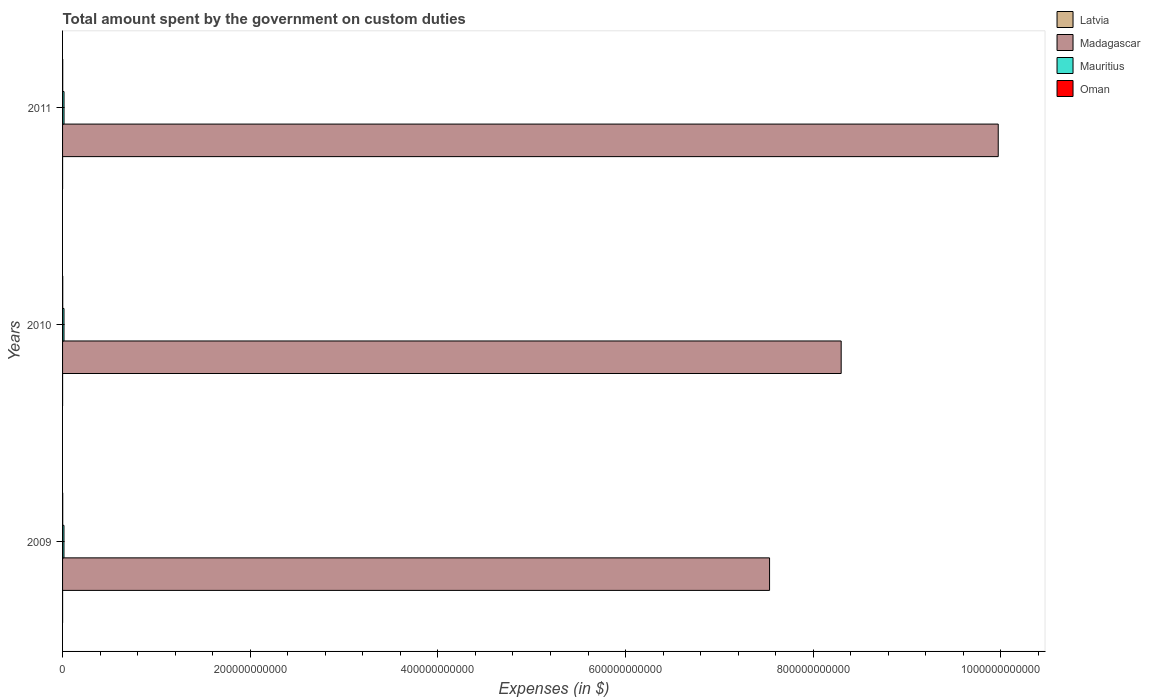Are the number of bars on each tick of the Y-axis equal?
Give a very brief answer. Yes. How many bars are there on the 1st tick from the top?
Give a very brief answer. 4. How many bars are there on the 1st tick from the bottom?
Your answer should be compact. 4. What is the amount spent on custom duties by the government in Mauritius in 2010?
Your response must be concise. 1.53e+09. Across all years, what is the maximum amount spent on custom duties by the government in Madagascar?
Provide a succinct answer. 9.97e+11. Across all years, what is the minimum amount spent on custom duties by the government in Madagascar?
Provide a succinct answer. 7.53e+11. In which year was the amount spent on custom duties by the government in Oman maximum?
Make the answer very short. 2010. In which year was the amount spent on custom duties by the government in Mauritius minimum?
Offer a terse response. 2009. What is the total amount spent on custom duties by the government in Madagascar in the graph?
Your response must be concise. 2.58e+12. What is the difference between the amount spent on custom duties by the government in Latvia in 2009 and that in 2011?
Provide a short and direct response. -5.80e+06. What is the difference between the amount spent on custom duties by the government in Mauritius in 2010 and the amount spent on custom duties by the government in Madagascar in 2009?
Provide a short and direct response. -7.52e+11. What is the average amount spent on custom duties by the government in Latvia per year?
Make the answer very short. 1.77e+07. In the year 2011, what is the difference between the amount spent on custom duties by the government in Oman and amount spent on custom duties by the government in Madagascar?
Make the answer very short. -9.97e+11. What is the ratio of the amount spent on custom duties by the government in Oman in 2010 to that in 2011?
Offer a very short reply. 1.11. Is the amount spent on custom duties by the government in Latvia in 2010 less than that in 2011?
Give a very brief answer. Yes. Is the difference between the amount spent on custom duties by the government in Oman in 2009 and 2010 greater than the difference between the amount spent on custom duties by the government in Madagascar in 2009 and 2010?
Ensure brevity in your answer.  Yes. What is the difference between the highest and the second highest amount spent on custom duties by the government in Latvia?
Ensure brevity in your answer.  3.60e+06. What is the difference between the highest and the lowest amount spent on custom duties by the government in Oman?
Provide a succinct answer. 2.15e+07. In how many years, is the amount spent on custom duties by the government in Latvia greater than the average amount spent on custom duties by the government in Latvia taken over all years?
Provide a short and direct response. 1. Is the sum of the amount spent on custom duties by the government in Latvia in 2010 and 2011 greater than the maximum amount spent on custom duties by the government in Oman across all years?
Offer a terse response. No. Is it the case that in every year, the sum of the amount spent on custom duties by the government in Mauritius and amount spent on custom duties by the government in Madagascar is greater than the sum of amount spent on custom duties by the government in Latvia and amount spent on custom duties by the government in Oman?
Your answer should be very brief. No. What does the 3rd bar from the top in 2009 represents?
Your answer should be compact. Madagascar. What does the 4th bar from the bottom in 2010 represents?
Keep it short and to the point. Oman. How many bars are there?
Your answer should be very brief. 12. Are all the bars in the graph horizontal?
Keep it short and to the point. Yes. How many years are there in the graph?
Provide a succinct answer. 3. What is the difference between two consecutive major ticks on the X-axis?
Offer a terse response. 2.00e+11. Are the values on the major ticks of X-axis written in scientific E-notation?
Your answer should be compact. No. Does the graph contain any zero values?
Ensure brevity in your answer.  No. Does the graph contain grids?
Your answer should be very brief. No. What is the title of the graph?
Give a very brief answer. Total amount spent by the government on custom duties. What is the label or title of the X-axis?
Provide a short and direct response. Expenses (in $). What is the Expenses (in $) in Latvia in 2009?
Offer a very short reply. 1.51e+07. What is the Expenses (in $) of Madagascar in 2009?
Offer a terse response. 7.53e+11. What is the Expenses (in $) in Mauritius in 2009?
Provide a short and direct response. 1.50e+09. What is the Expenses (in $) of Oman in 2009?
Your response must be concise. 1.58e+08. What is the Expenses (in $) of Latvia in 2010?
Offer a terse response. 1.73e+07. What is the Expenses (in $) in Madagascar in 2010?
Give a very brief answer. 8.30e+11. What is the Expenses (in $) in Mauritius in 2010?
Make the answer very short. 1.53e+09. What is the Expenses (in $) in Oman in 2010?
Your answer should be compact. 1.80e+08. What is the Expenses (in $) of Latvia in 2011?
Ensure brevity in your answer.  2.09e+07. What is the Expenses (in $) of Madagascar in 2011?
Make the answer very short. 9.97e+11. What is the Expenses (in $) of Mauritius in 2011?
Offer a very short reply. 1.56e+09. What is the Expenses (in $) of Oman in 2011?
Your response must be concise. 1.61e+08. Across all years, what is the maximum Expenses (in $) in Latvia?
Ensure brevity in your answer.  2.09e+07. Across all years, what is the maximum Expenses (in $) in Madagascar?
Your response must be concise. 9.97e+11. Across all years, what is the maximum Expenses (in $) of Mauritius?
Offer a very short reply. 1.56e+09. Across all years, what is the maximum Expenses (in $) of Oman?
Make the answer very short. 1.80e+08. Across all years, what is the minimum Expenses (in $) of Latvia?
Keep it short and to the point. 1.51e+07. Across all years, what is the minimum Expenses (in $) in Madagascar?
Provide a short and direct response. 7.53e+11. Across all years, what is the minimum Expenses (in $) in Mauritius?
Your response must be concise. 1.50e+09. Across all years, what is the minimum Expenses (in $) of Oman?
Provide a short and direct response. 1.58e+08. What is the total Expenses (in $) of Latvia in the graph?
Provide a short and direct response. 5.32e+07. What is the total Expenses (in $) of Madagascar in the graph?
Your answer should be very brief. 2.58e+12. What is the total Expenses (in $) of Mauritius in the graph?
Your answer should be very brief. 4.59e+09. What is the total Expenses (in $) of Oman in the graph?
Keep it short and to the point. 4.99e+08. What is the difference between the Expenses (in $) in Latvia in 2009 and that in 2010?
Keep it short and to the point. -2.20e+06. What is the difference between the Expenses (in $) of Madagascar in 2009 and that in 2010?
Offer a very short reply. -7.63e+1. What is the difference between the Expenses (in $) in Mauritius in 2009 and that in 2010?
Your response must be concise. -2.40e+07. What is the difference between the Expenses (in $) of Oman in 2009 and that in 2010?
Offer a terse response. -2.15e+07. What is the difference between the Expenses (in $) of Latvia in 2009 and that in 2011?
Offer a very short reply. -5.80e+06. What is the difference between the Expenses (in $) of Madagascar in 2009 and that in 2011?
Provide a short and direct response. -2.44e+11. What is the difference between the Expenses (in $) in Mauritius in 2009 and that in 2011?
Your answer should be very brief. -5.91e+07. What is the difference between the Expenses (in $) in Oman in 2009 and that in 2011?
Give a very brief answer. -3.10e+06. What is the difference between the Expenses (in $) of Latvia in 2010 and that in 2011?
Make the answer very short. -3.60e+06. What is the difference between the Expenses (in $) of Madagascar in 2010 and that in 2011?
Provide a succinct answer. -1.67e+11. What is the difference between the Expenses (in $) in Mauritius in 2010 and that in 2011?
Your response must be concise. -3.51e+07. What is the difference between the Expenses (in $) of Oman in 2010 and that in 2011?
Offer a terse response. 1.84e+07. What is the difference between the Expenses (in $) in Latvia in 2009 and the Expenses (in $) in Madagascar in 2010?
Make the answer very short. -8.30e+11. What is the difference between the Expenses (in $) of Latvia in 2009 and the Expenses (in $) of Mauritius in 2010?
Provide a succinct answer. -1.51e+09. What is the difference between the Expenses (in $) of Latvia in 2009 and the Expenses (in $) of Oman in 2010?
Give a very brief answer. -1.65e+08. What is the difference between the Expenses (in $) in Madagascar in 2009 and the Expenses (in $) in Mauritius in 2010?
Offer a very short reply. 7.52e+11. What is the difference between the Expenses (in $) in Madagascar in 2009 and the Expenses (in $) in Oman in 2010?
Offer a terse response. 7.53e+11. What is the difference between the Expenses (in $) in Mauritius in 2009 and the Expenses (in $) in Oman in 2010?
Offer a terse response. 1.32e+09. What is the difference between the Expenses (in $) in Latvia in 2009 and the Expenses (in $) in Madagascar in 2011?
Offer a very short reply. -9.97e+11. What is the difference between the Expenses (in $) in Latvia in 2009 and the Expenses (in $) in Mauritius in 2011?
Your answer should be very brief. -1.55e+09. What is the difference between the Expenses (in $) in Latvia in 2009 and the Expenses (in $) in Oman in 2011?
Your answer should be compact. -1.46e+08. What is the difference between the Expenses (in $) of Madagascar in 2009 and the Expenses (in $) of Mauritius in 2011?
Provide a short and direct response. 7.52e+11. What is the difference between the Expenses (in $) in Madagascar in 2009 and the Expenses (in $) in Oman in 2011?
Offer a very short reply. 7.53e+11. What is the difference between the Expenses (in $) of Mauritius in 2009 and the Expenses (in $) of Oman in 2011?
Provide a short and direct response. 1.34e+09. What is the difference between the Expenses (in $) in Latvia in 2010 and the Expenses (in $) in Madagascar in 2011?
Make the answer very short. -9.97e+11. What is the difference between the Expenses (in $) of Latvia in 2010 and the Expenses (in $) of Mauritius in 2011?
Your response must be concise. -1.54e+09. What is the difference between the Expenses (in $) of Latvia in 2010 and the Expenses (in $) of Oman in 2011?
Your answer should be compact. -1.44e+08. What is the difference between the Expenses (in $) in Madagascar in 2010 and the Expenses (in $) in Mauritius in 2011?
Offer a terse response. 8.28e+11. What is the difference between the Expenses (in $) of Madagascar in 2010 and the Expenses (in $) of Oman in 2011?
Keep it short and to the point. 8.30e+11. What is the difference between the Expenses (in $) of Mauritius in 2010 and the Expenses (in $) of Oman in 2011?
Your response must be concise. 1.36e+09. What is the average Expenses (in $) of Latvia per year?
Ensure brevity in your answer.  1.77e+07. What is the average Expenses (in $) of Madagascar per year?
Your response must be concise. 8.60e+11. What is the average Expenses (in $) of Mauritius per year?
Offer a terse response. 1.53e+09. What is the average Expenses (in $) of Oman per year?
Provide a succinct answer. 1.66e+08. In the year 2009, what is the difference between the Expenses (in $) in Latvia and Expenses (in $) in Madagascar?
Provide a short and direct response. -7.53e+11. In the year 2009, what is the difference between the Expenses (in $) of Latvia and Expenses (in $) of Mauritius?
Give a very brief answer. -1.49e+09. In the year 2009, what is the difference between the Expenses (in $) of Latvia and Expenses (in $) of Oman?
Ensure brevity in your answer.  -1.43e+08. In the year 2009, what is the difference between the Expenses (in $) in Madagascar and Expenses (in $) in Mauritius?
Your answer should be compact. 7.52e+11. In the year 2009, what is the difference between the Expenses (in $) of Madagascar and Expenses (in $) of Oman?
Make the answer very short. 7.53e+11. In the year 2009, what is the difference between the Expenses (in $) of Mauritius and Expenses (in $) of Oman?
Give a very brief answer. 1.34e+09. In the year 2010, what is the difference between the Expenses (in $) in Latvia and Expenses (in $) in Madagascar?
Give a very brief answer. -8.30e+11. In the year 2010, what is the difference between the Expenses (in $) of Latvia and Expenses (in $) of Mauritius?
Make the answer very short. -1.51e+09. In the year 2010, what is the difference between the Expenses (in $) in Latvia and Expenses (in $) in Oman?
Offer a terse response. -1.62e+08. In the year 2010, what is the difference between the Expenses (in $) in Madagascar and Expenses (in $) in Mauritius?
Give a very brief answer. 8.28e+11. In the year 2010, what is the difference between the Expenses (in $) in Madagascar and Expenses (in $) in Oman?
Your response must be concise. 8.30e+11. In the year 2010, what is the difference between the Expenses (in $) of Mauritius and Expenses (in $) of Oman?
Offer a terse response. 1.35e+09. In the year 2011, what is the difference between the Expenses (in $) of Latvia and Expenses (in $) of Madagascar?
Offer a very short reply. -9.97e+11. In the year 2011, what is the difference between the Expenses (in $) of Latvia and Expenses (in $) of Mauritius?
Your answer should be compact. -1.54e+09. In the year 2011, what is the difference between the Expenses (in $) in Latvia and Expenses (in $) in Oman?
Make the answer very short. -1.40e+08. In the year 2011, what is the difference between the Expenses (in $) in Madagascar and Expenses (in $) in Mauritius?
Your answer should be compact. 9.96e+11. In the year 2011, what is the difference between the Expenses (in $) in Madagascar and Expenses (in $) in Oman?
Offer a terse response. 9.97e+11. In the year 2011, what is the difference between the Expenses (in $) of Mauritius and Expenses (in $) of Oman?
Offer a terse response. 1.40e+09. What is the ratio of the Expenses (in $) in Latvia in 2009 to that in 2010?
Provide a succinct answer. 0.87. What is the ratio of the Expenses (in $) in Madagascar in 2009 to that in 2010?
Provide a succinct answer. 0.91. What is the ratio of the Expenses (in $) of Mauritius in 2009 to that in 2010?
Offer a terse response. 0.98. What is the ratio of the Expenses (in $) of Oman in 2009 to that in 2010?
Provide a short and direct response. 0.88. What is the ratio of the Expenses (in $) of Latvia in 2009 to that in 2011?
Keep it short and to the point. 0.72. What is the ratio of the Expenses (in $) of Madagascar in 2009 to that in 2011?
Provide a short and direct response. 0.76. What is the ratio of the Expenses (in $) of Mauritius in 2009 to that in 2011?
Offer a terse response. 0.96. What is the ratio of the Expenses (in $) of Oman in 2009 to that in 2011?
Give a very brief answer. 0.98. What is the ratio of the Expenses (in $) in Latvia in 2010 to that in 2011?
Offer a very short reply. 0.83. What is the ratio of the Expenses (in $) in Madagascar in 2010 to that in 2011?
Your response must be concise. 0.83. What is the ratio of the Expenses (in $) of Mauritius in 2010 to that in 2011?
Give a very brief answer. 0.98. What is the ratio of the Expenses (in $) in Oman in 2010 to that in 2011?
Make the answer very short. 1.11. What is the difference between the highest and the second highest Expenses (in $) in Latvia?
Ensure brevity in your answer.  3.60e+06. What is the difference between the highest and the second highest Expenses (in $) of Madagascar?
Your answer should be very brief. 1.67e+11. What is the difference between the highest and the second highest Expenses (in $) of Mauritius?
Offer a terse response. 3.51e+07. What is the difference between the highest and the second highest Expenses (in $) of Oman?
Your response must be concise. 1.84e+07. What is the difference between the highest and the lowest Expenses (in $) in Latvia?
Provide a short and direct response. 5.80e+06. What is the difference between the highest and the lowest Expenses (in $) of Madagascar?
Provide a short and direct response. 2.44e+11. What is the difference between the highest and the lowest Expenses (in $) of Mauritius?
Your answer should be very brief. 5.91e+07. What is the difference between the highest and the lowest Expenses (in $) in Oman?
Offer a terse response. 2.15e+07. 